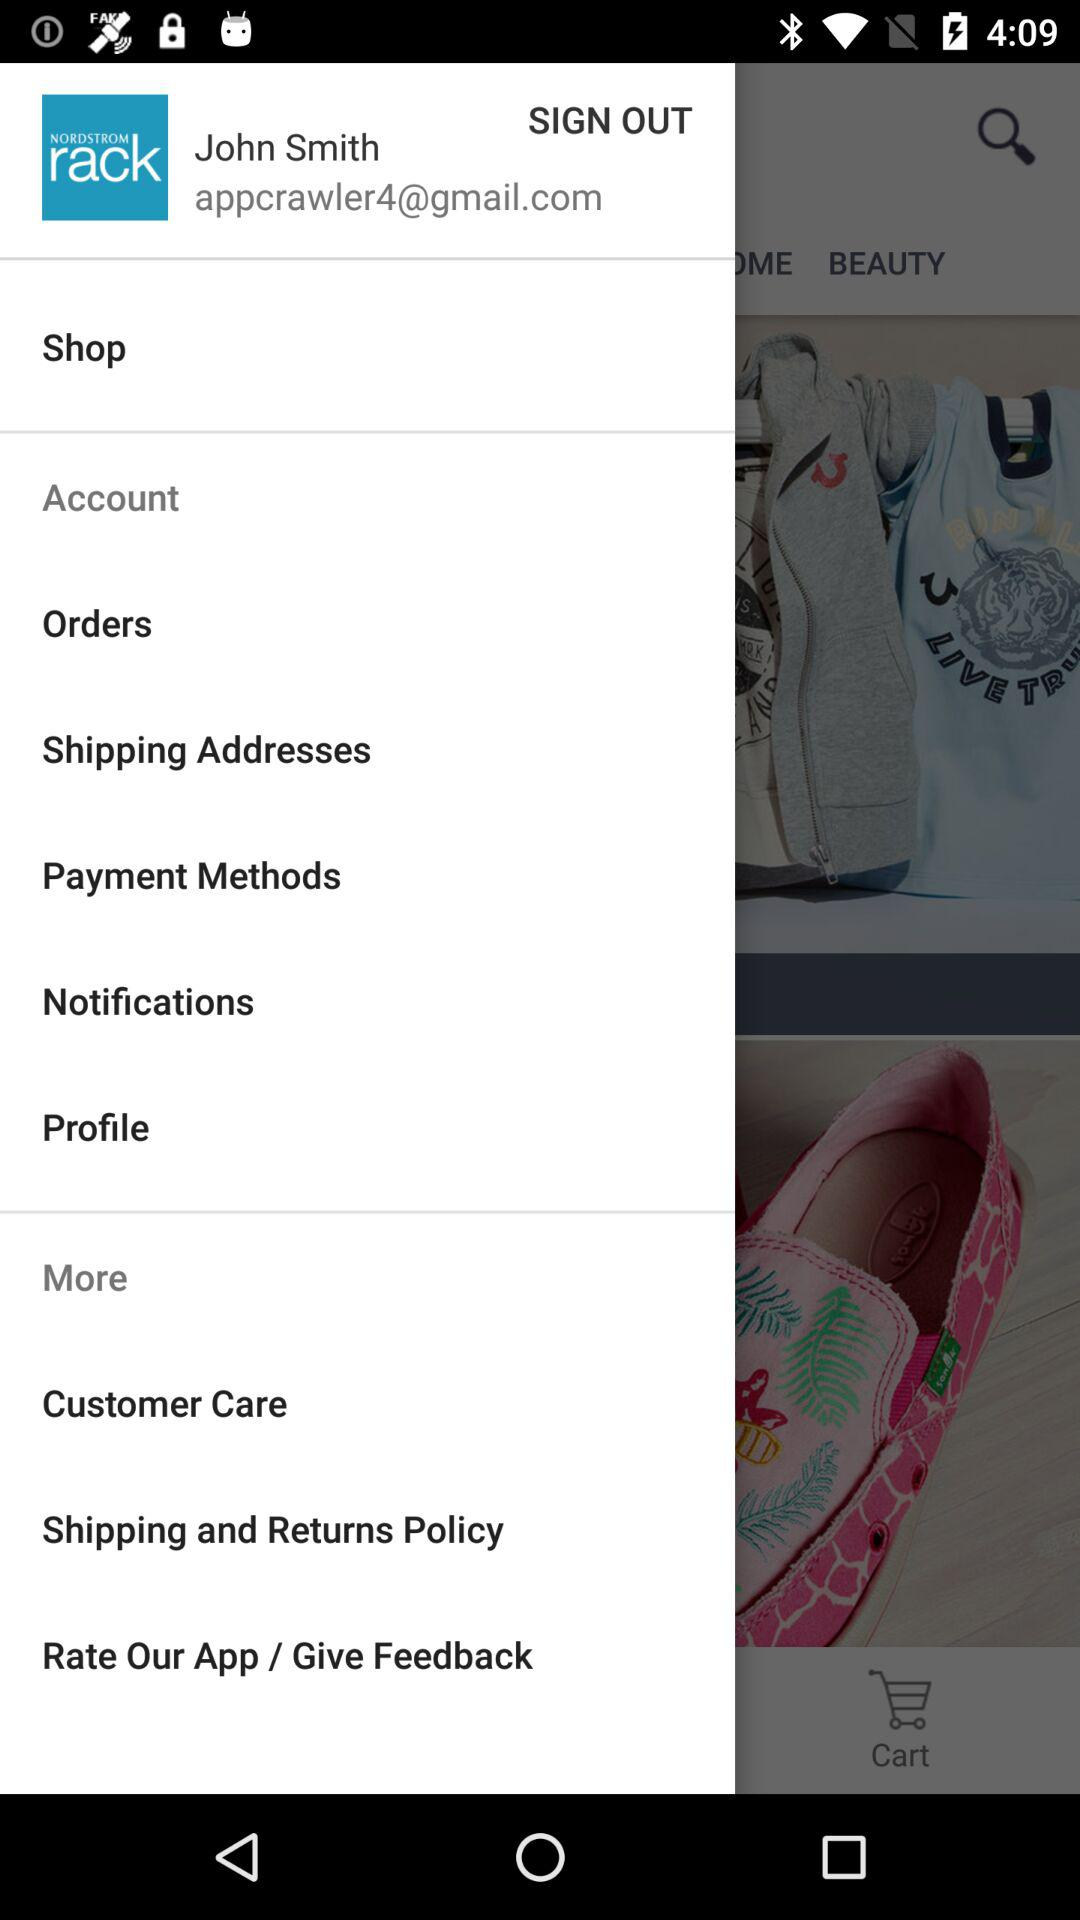What is the name of the application? The name of the application is "NORDSTROM rack". 